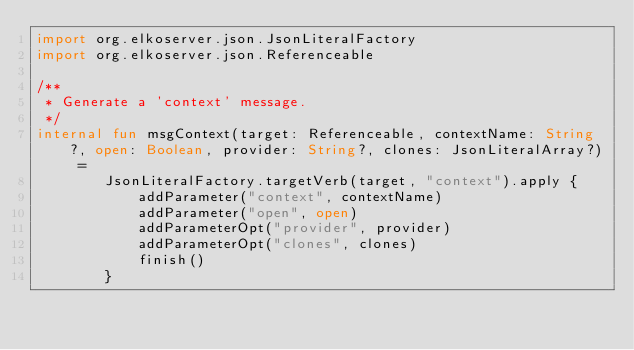Convert code to text. <code><loc_0><loc_0><loc_500><loc_500><_Kotlin_>import org.elkoserver.json.JsonLiteralFactory
import org.elkoserver.json.Referenceable

/**
 * Generate a 'context' message.
 */
internal fun msgContext(target: Referenceable, contextName: String?, open: Boolean, provider: String?, clones: JsonLiteralArray?) =
        JsonLiteralFactory.targetVerb(target, "context").apply {
            addParameter("context", contextName)
            addParameter("open", open)
            addParameterOpt("provider", provider)
            addParameterOpt("clones", clones)
            finish()
        }
</code> 